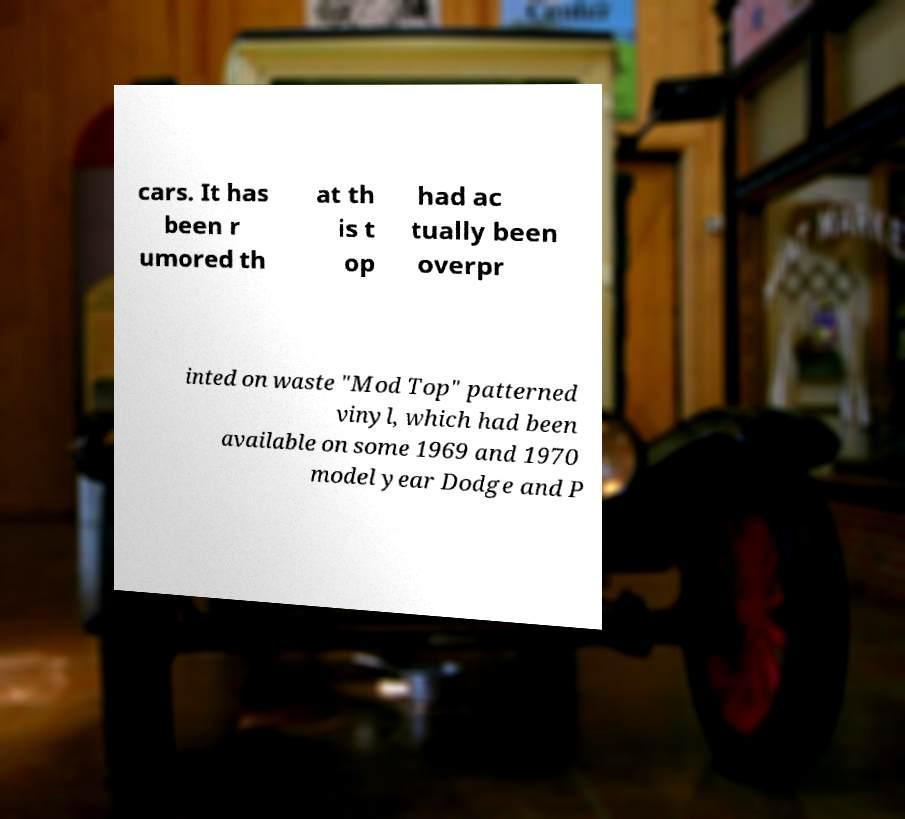Can you read and provide the text displayed in the image?This photo seems to have some interesting text. Can you extract and type it out for me? cars. It has been r umored th at th is t op had ac tually been overpr inted on waste "Mod Top" patterned vinyl, which had been available on some 1969 and 1970 model year Dodge and P 